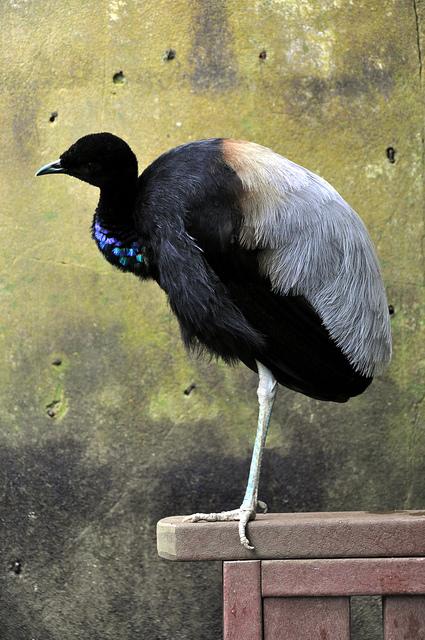Will the bird stay perched there for a long time?
Short answer required. Yes. What is the bird perched on?
Answer briefly. Bench. Is this a peacock?
Answer briefly. No. 